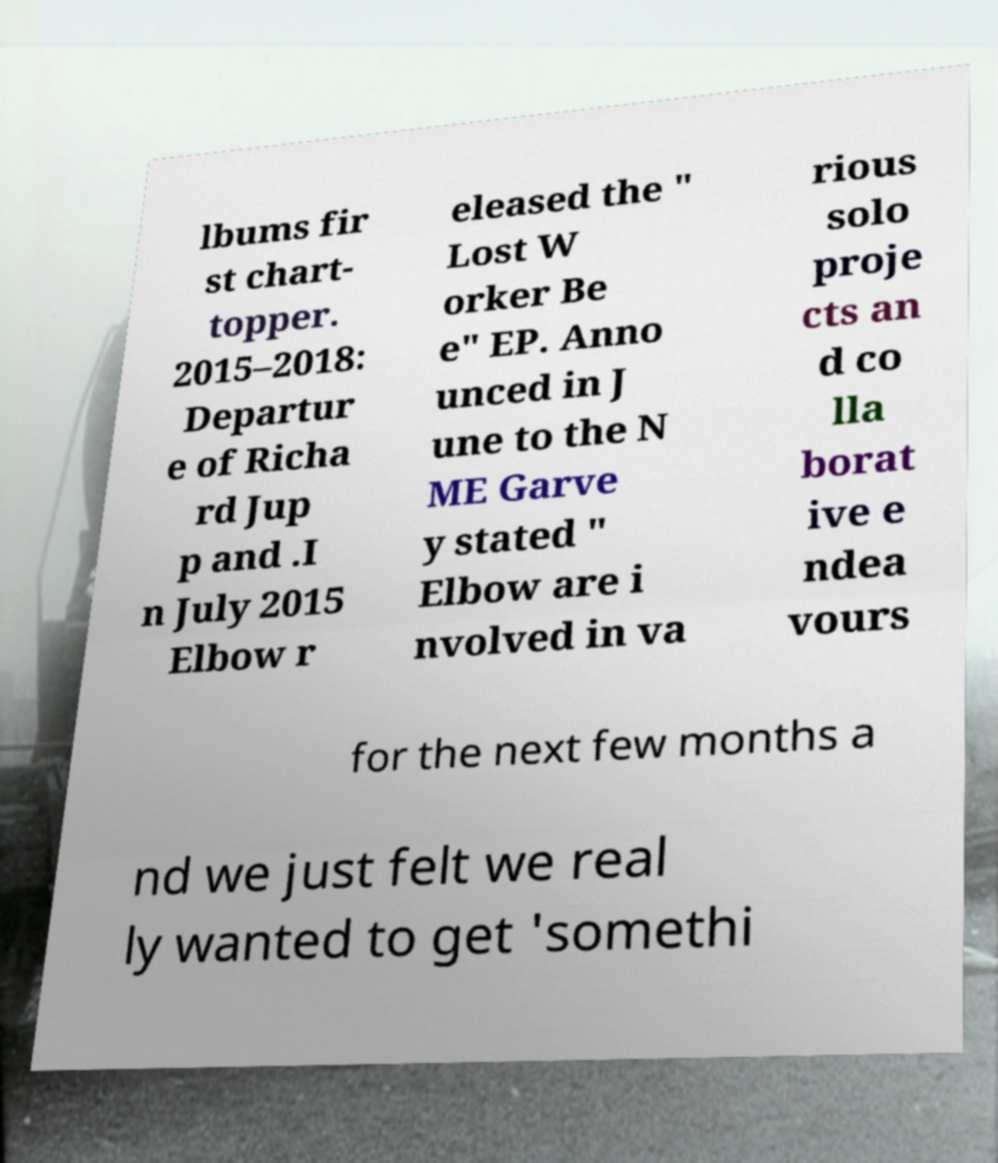Could you assist in decoding the text presented in this image and type it out clearly? lbums fir st chart- topper. 2015–2018: Departur e of Richa rd Jup p and .I n July 2015 Elbow r eleased the " Lost W orker Be e" EP. Anno unced in J une to the N ME Garve y stated " Elbow are i nvolved in va rious solo proje cts an d co lla borat ive e ndea vours for the next few months a nd we just felt we real ly wanted to get 'somethi 